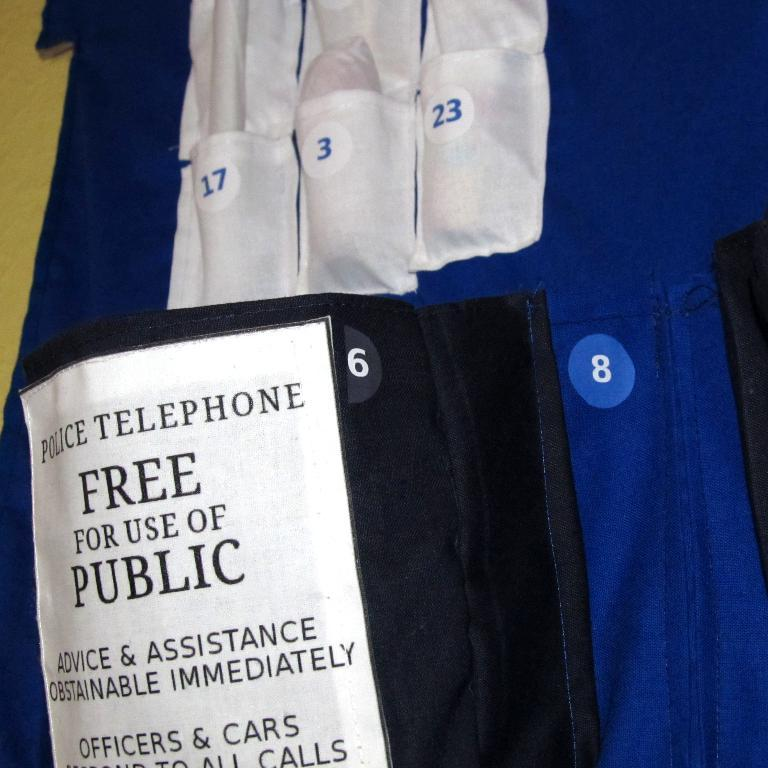<image>
Summarize the visual content of the image. The public telephone is free for the use of the public. 